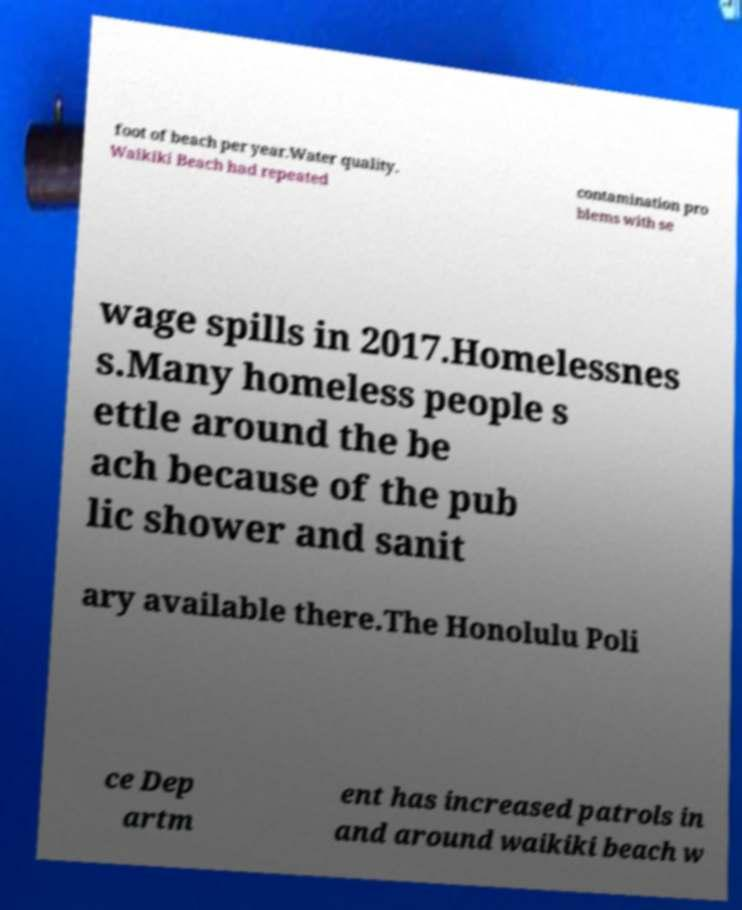There's text embedded in this image that I need extracted. Can you transcribe it verbatim? foot of beach per year.Water quality. Waikiki Beach had repeated contamination pro blems with se wage spills in 2017.Homelessnes s.Many homeless people s ettle around the be ach because of the pub lic shower and sanit ary available there.The Honolulu Poli ce Dep artm ent has increased patrols in and around waikiki beach w 